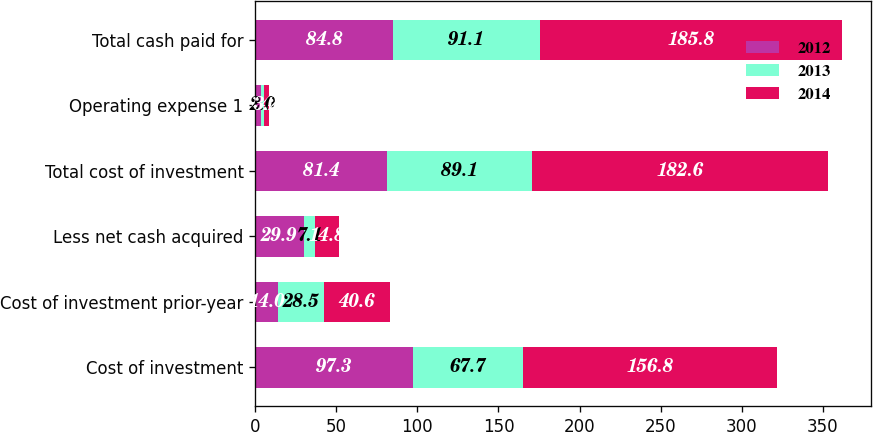Convert chart. <chart><loc_0><loc_0><loc_500><loc_500><stacked_bar_chart><ecel><fcel>Cost of investment<fcel>Cost of investment prior-year<fcel>Less net cash acquired<fcel>Total cost of investment<fcel>Operating expense 1<fcel>Total cash paid for<nl><fcel>2012<fcel>97.3<fcel>14<fcel>29.9<fcel>81.4<fcel>3.4<fcel>84.8<nl><fcel>2013<fcel>67.7<fcel>28.5<fcel>7.1<fcel>89.1<fcel>2<fcel>91.1<nl><fcel>2014<fcel>156.8<fcel>40.6<fcel>14.8<fcel>182.6<fcel>3.2<fcel>185.8<nl></chart> 